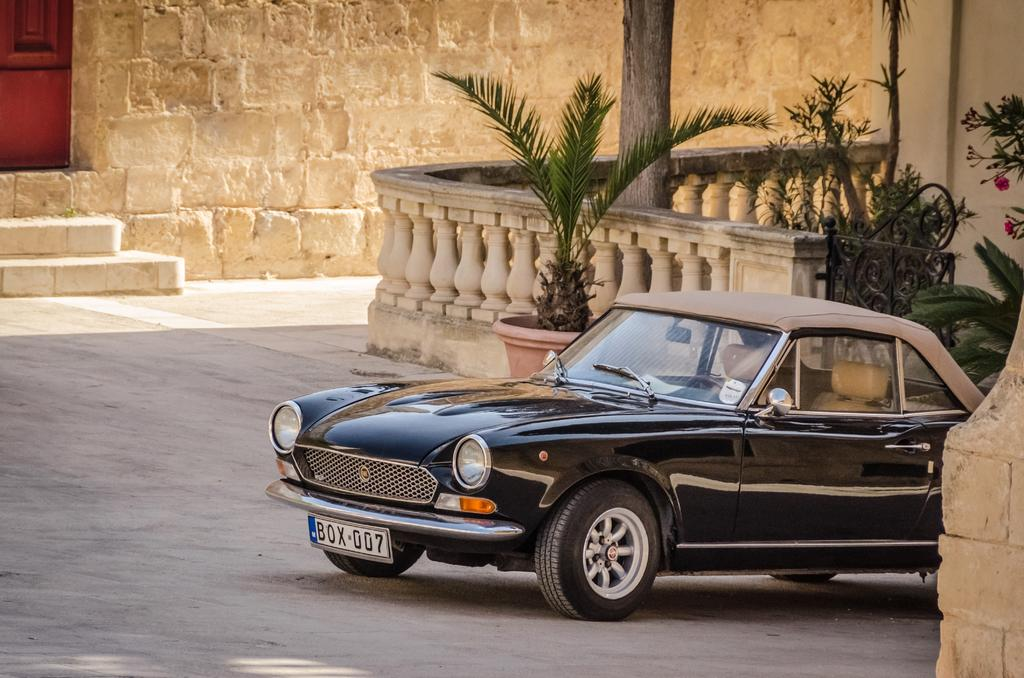What is the main subject of the image? The main subject of the image is a car. What features can be seen on the car? The car has headlights and a number plate. What type of surface is visible in the image? There is a road in the image. Are there any architectural features present? Yes, there are stairs, a fence, a plant pot, a pole, and a wall in the image. What type of stocking can be seen on the car's tires in the image? There are no stockings present on the car's tires in the image. Can you describe the spark generated by the friction between the car and the road in the image? There is no spark generated by the friction between the car and the road in the image, as the car is stationary. 